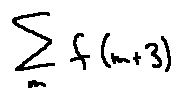Convert formula to latex. <formula><loc_0><loc_0><loc_500><loc_500>\sum \lim i t s _ { m } f ( m + 3 )</formula> 